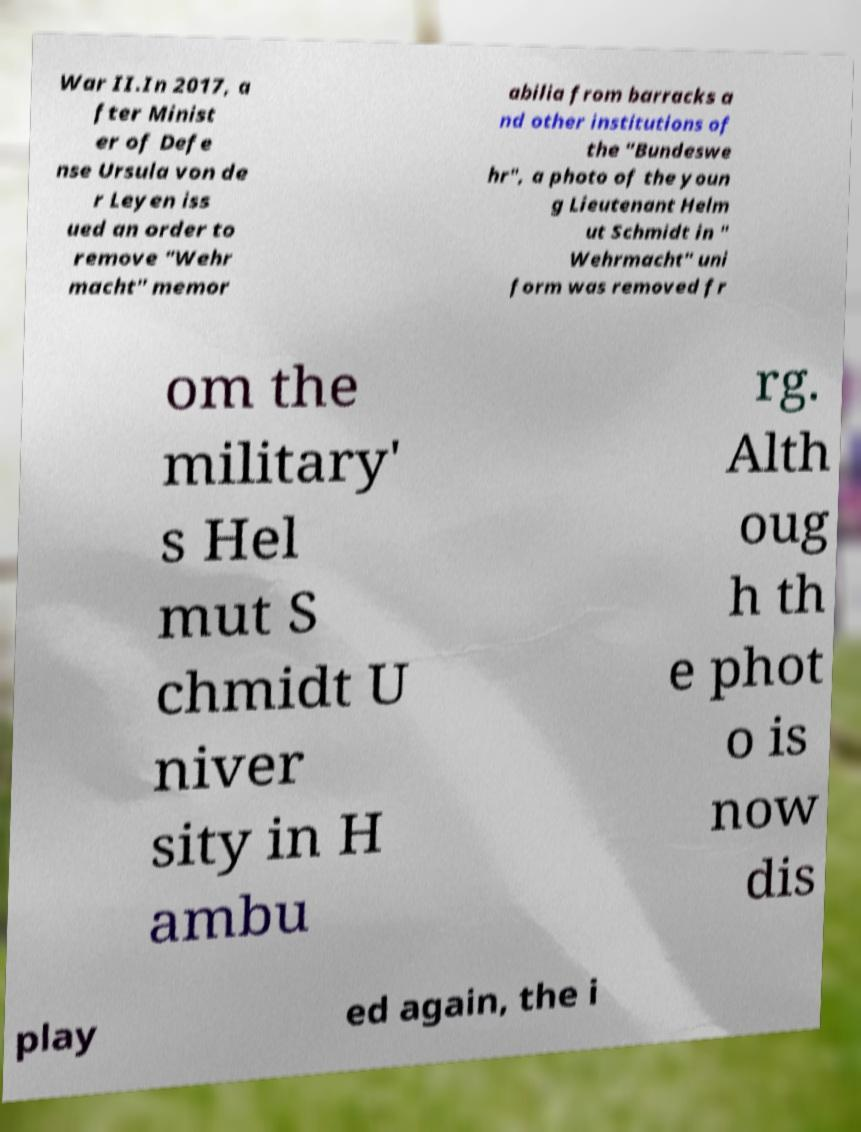What messages or text are displayed in this image? I need them in a readable, typed format. War II.In 2017, a fter Minist er of Defe nse Ursula von de r Leyen iss ued an order to remove "Wehr macht" memor abilia from barracks a nd other institutions of the "Bundeswe hr", a photo of the youn g Lieutenant Helm ut Schmidt in " Wehrmacht" uni form was removed fr om the military' s Hel mut S chmidt U niver sity in H ambu rg. Alth oug h th e phot o is now dis play ed again, the i 